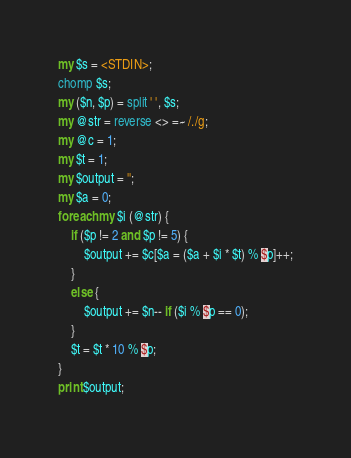<code> <loc_0><loc_0><loc_500><loc_500><_Perl_>my $s = <STDIN>;
chomp $s;
my ($n, $p) = split ' ', $s;
my @str = reverse <> =~ /./g;
my @c = 1;
my $t = 1;
my $output = '';
my $a = 0;
foreach my $i (@str) {
    if ($p != 2 and $p != 5) {
        $output += $c[$a = ($a + $i * $t) % $p]++;
    }
    else {
        $output += $n-- if ($i % $p == 0);
    }
    $t = $t * 10 % $p;
}
print $output;</code> 